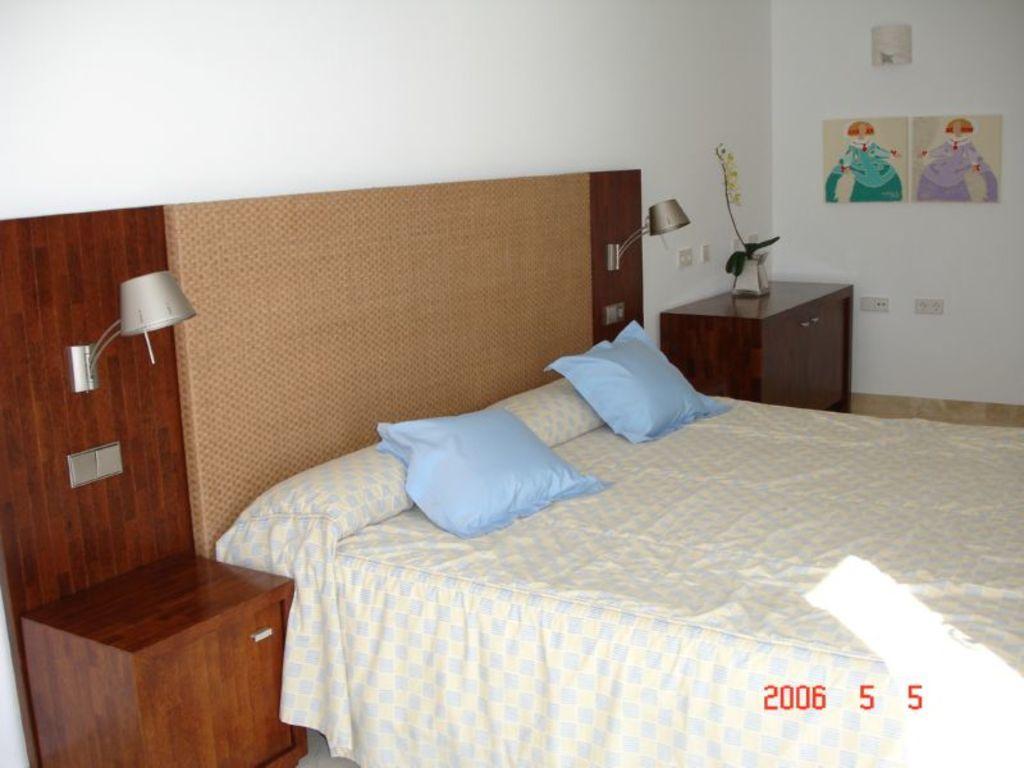Could you give a brief overview of what you see in this image? In the center of the image there is a bed. There are pillows on the bed. In the background of the image there is wall. There are posters. There is a table on which there are flower vase. At the bottom of the image there is text. 